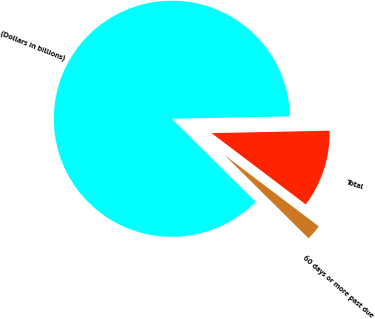<chart> <loc_0><loc_0><loc_500><loc_500><pie_chart><fcel>(Dollars in billions)<fcel>Total<fcel>60 days or more past due<nl><fcel>87.24%<fcel>10.64%<fcel>2.12%<nl></chart> 